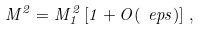<formula> <loc_0><loc_0><loc_500><loc_500>M ^ { 2 } = M _ { 1 } ^ { 2 } \left [ 1 + O ( \ e p s ) \right ] \, ,</formula> 